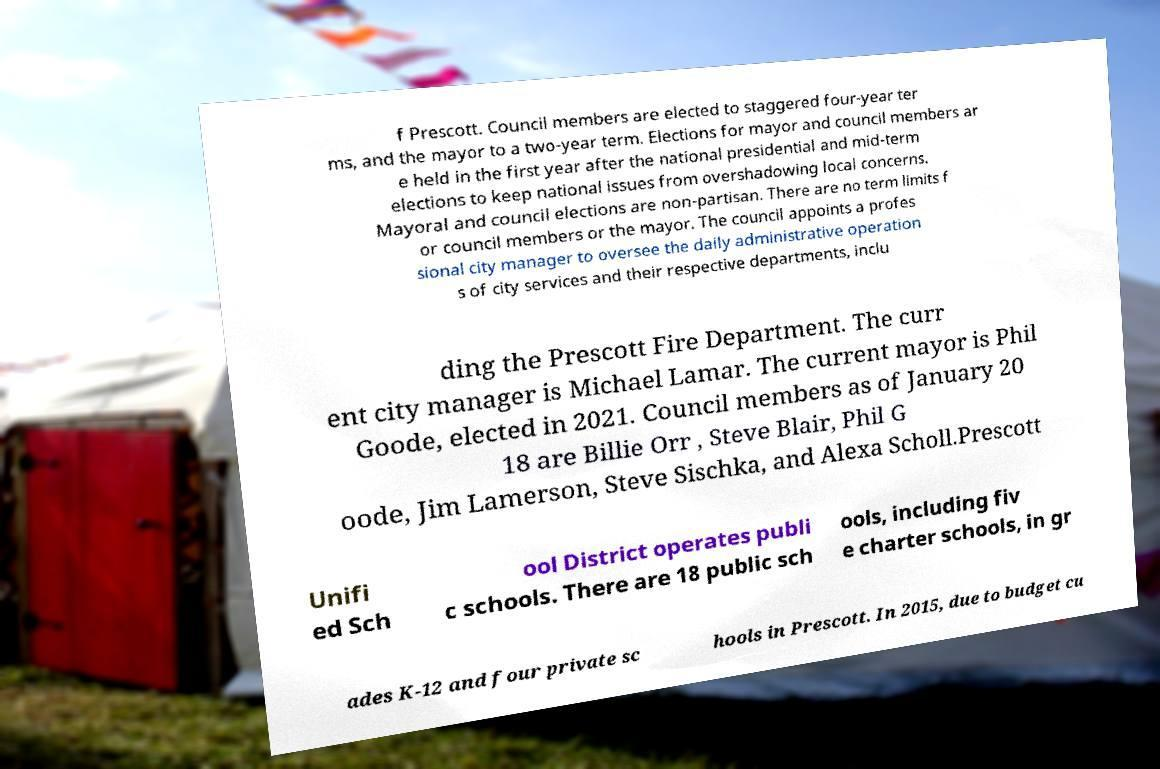I need the written content from this picture converted into text. Can you do that? f Prescott. Council members are elected to staggered four-year ter ms, and the mayor to a two-year term. Elections for mayor and council members ar e held in the first year after the national presidential and mid-term elections to keep national issues from overshadowing local concerns. Mayoral and council elections are non-partisan. There are no term limits f or council members or the mayor. The council appoints a profes sional city manager to oversee the daily administrative operation s of city services and their respective departments, inclu ding the Prescott Fire Department. The curr ent city manager is Michael Lamar. The current mayor is Phil Goode, elected in 2021. Council members as of January 20 18 are Billie Orr , Steve Blair, Phil G oode, Jim Lamerson, Steve Sischka, and Alexa Scholl.Prescott Unifi ed Sch ool District operates publi c schools. There are 18 public sch ools, including fiv e charter schools, in gr ades K-12 and four private sc hools in Prescott. In 2015, due to budget cu 